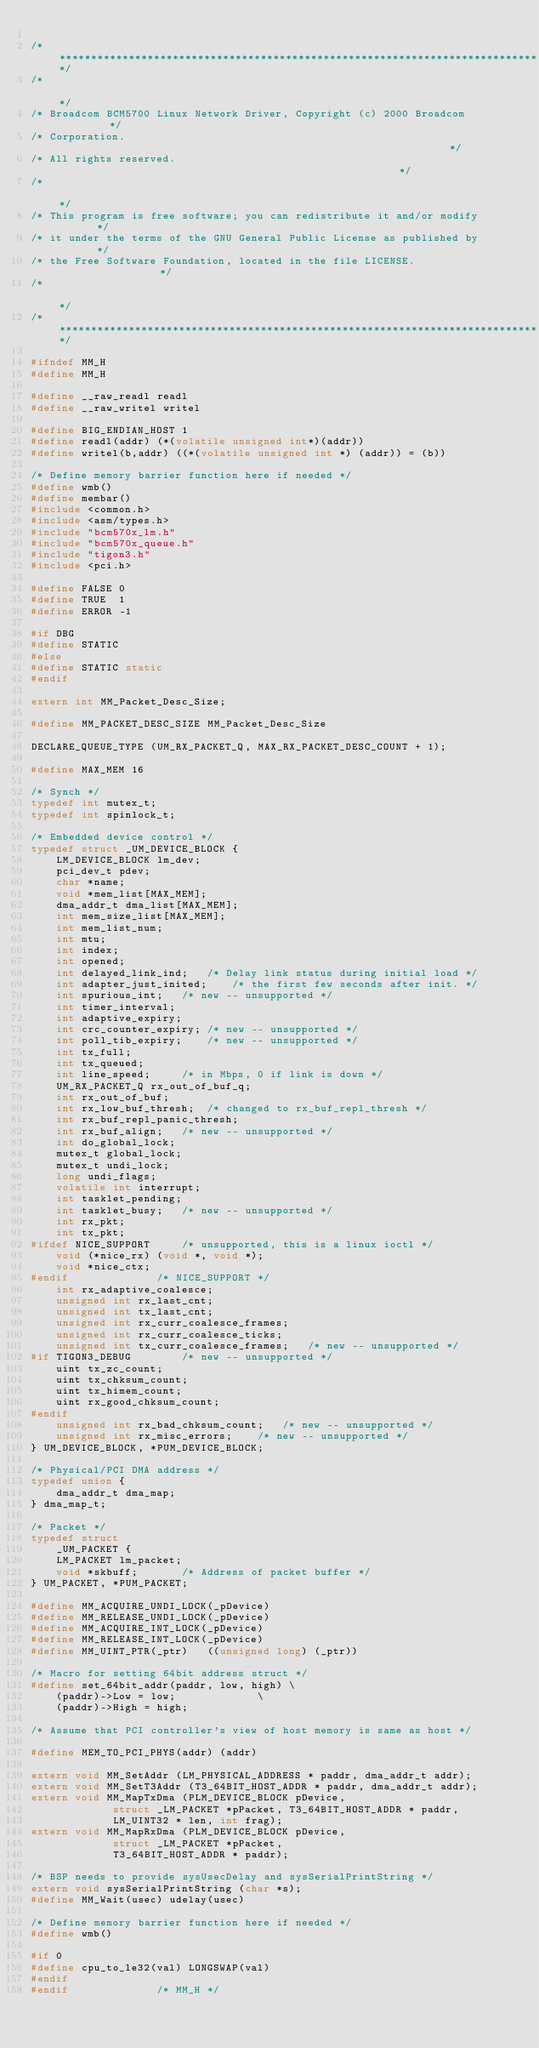<code> <loc_0><loc_0><loc_500><loc_500><_C_>
/******************************************************************************/
/*                                                                            */
/* Broadcom BCM5700 Linux Network Driver, Copyright (c) 2000 Broadcom         */
/* Corporation.                                                               */
/* All rights reserved.                                                       */
/*                                                                            */
/* This program is free software; you can redistribute it and/or modify       */
/* it under the terms of the GNU General Public License as published by       */
/* the Free Software Foundation, located in the file LICENSE.                 */
/*                                                                            */
/******************************************************************************/

#ifndef MM_H
#define MM_H

#define __raw_readl readl
#define __raw_writel writel

#define BIG_ENDIAN_HOST 1
#define readl(addr) (*(volatile unsigned int*)(addr))
#define writel(b,addr) ((*(volatile unsigned int *) (addr)) = (b))

/* Define memory barrier function here if needed */
#define wmb()
#define membar()
#include <common.h>
#include <asm/types.h>
#include "bcm570x_lm.h"
#include "bcm570x_queue.h"
#include "tigon3.h"
#include <pci.h>

#define FALSE 0
#define TRUE  1
#define ERROR -1

#if DBG
#define STATIC
#else
#define STATIC static
#endif

extern int MM_Packet_Desc_Size;

#define MM_PACKET_DESC_SIZE MM_Packet_Desc_Size

DECLARE_QUEUE_TYPE (UM_RX_PACKET_Q, MAX_RX_PACKET_DESC_COUNT + 1);

#define MAX_MEM 16

/* Synch */
typedef int mutex_t;
typedef int spinlock_t;

/* Embedded device control */
typedef struct _UM_DEVICE_BLOCK {
	LM_DEVICE_BLOCK lm_dev;
	pci_dev_t pdev;
	char *name;
	void *mem_list[MAX_MEM];
	dma_addr_t dma_list[MAX_MEM];
	int mem_size_list[MAX_MEM];
	int mem_list_num;
	int mtu;
	int index;
	int opened;
	int delayed_link_ind;	/* Delay link status during initial load */
	int adapter_just_inited;	/* the first few seconds after init. */
	int spurious_int;	/* new -- unsupported */
	int timer_interval;
	int adaptive_expiry;
	int crc_counter_expiry;	/* new -- unsupported */
	int poll_tib_expiry;	/* new -- unsupported */
	int tx_full;
	int tx_queued;
	int line_speed;		/* in Mbps, 0 if link is down */
	UM_RX_PACKET_Q rx_out_of_buf_q;
	int rx_out_of_buf;
	int rx_low_buf_thresh;	/* changed to rx_buf_repl_thresh */
	int rx_buf_repl_panic_thresh;
	int rx_buf_align;	/* new -- unsupported */
	int do_global_lock;
	mutex_t global_lock;
	mutex_t undi_lock;
	long undi_flags;
	volatile int interrupt;
	int tasklet_pending;
	int tasklet_busy;	/* new -- unsupported */
	int rx_pkt;
	int tx_pkt;
#ifdef NICE_SUPPORT		/* unsupported, this is a linux ioctl */
	void (*nice_rx) (void *, void *);
	void *nice_ctx;
#endif				/* NICE_SUPPORT */
	int rx_adaptive_coalesce;
	unsigned int rx_last_cnt;
	unsigned int tx_last_cnt;
	unsigned int rx_curr_coalesce_frames;
	unsigned int rx_curr_coalesce_ticks;
	unsigned int tx_curr_coalesce_frames;	/* new -- unsupported */
#if TIGON3_DEBUG		/* new -- unsupported */
	uint tx_zc_count;
	uint tx_chksum_count;
	uint tx_himem_count;
	uint rx_good_chksum_count;
#endif
	unsigned int rx_bad_chksum_count;	/* new -- unsupported */
	unsigned int rx_misc_errors;	/* new -- unsupported */
} UM_DEVICE_BLOCK, *PUM_DEVICE_BLOCK;

/* Physical/PCI DMA address */
typedef union {
	dma_addr_t dma_map;
} dma_map_t;

/* Packet */
typedef struct
    _UM_PACKET {
	LM_PACKET lm_packet;
	void *skbuff;		/* Address of packet buffer */
} UM_PACKET, *PUM_PACKET;

#define MM_ACQUIRE_UNDI_LOCK(_pDevice)
#define MM_RELEASE_UNDI_LOCK(_pDevice)
#define MM_ACQUIRE_INT_LOCK(_pDevice)
#define MM_RELEASE_INT_LOCK(_pDevice)
#define MM_UINT_PTR(_ptr)   ((unsigned long) (_ptr))

/* Macro for setting 64bit address struct */
#define set_64bit_addr(paddr, low, high) \
	(paddr)->Low = low;             \
	(paddr)->High = high;

/* Assume that PCI controller's view of host memory is same as host */

#define MEM_TO_PCI_PHYS(addr) (addr)

extern void MM_SetAddr (LM_PHYSICAL_ADDRESS * paddr, dma_addr_t addr);
extern void MM_SetT3Addr (T3_64BIT_HOST_ADDR * paddr, dma_addr_t addr);
extern void MM_MapTxDma (PLM_DEVICE_BLOCK pDevice,
			 struct _LM_PACKET *pPacket, T3_64BIT_HOST_ADDR * paddr,
			 LM_UINT32 * len, int frag);
extern void MM_MapRxDma (PLM_DEVICE_BLOCK pDevice,
			 struct _LM_PACKET *pPacket,
			 T3_64BIT_HOST_ADDR * paddr);

/* BSP needs to provide sysUsecDelay and sysSerialPrintString */
extern void sysSerialPrintString (char *s);
#define MM_Wait(usec) udelay(usec)

/* Define memory barrier function here if needed */
#define wmb()

#if 0
#define cpu_to_le32(val) LONGSWAP(val)
#endif
#endif				/* MM_H */
</code> 